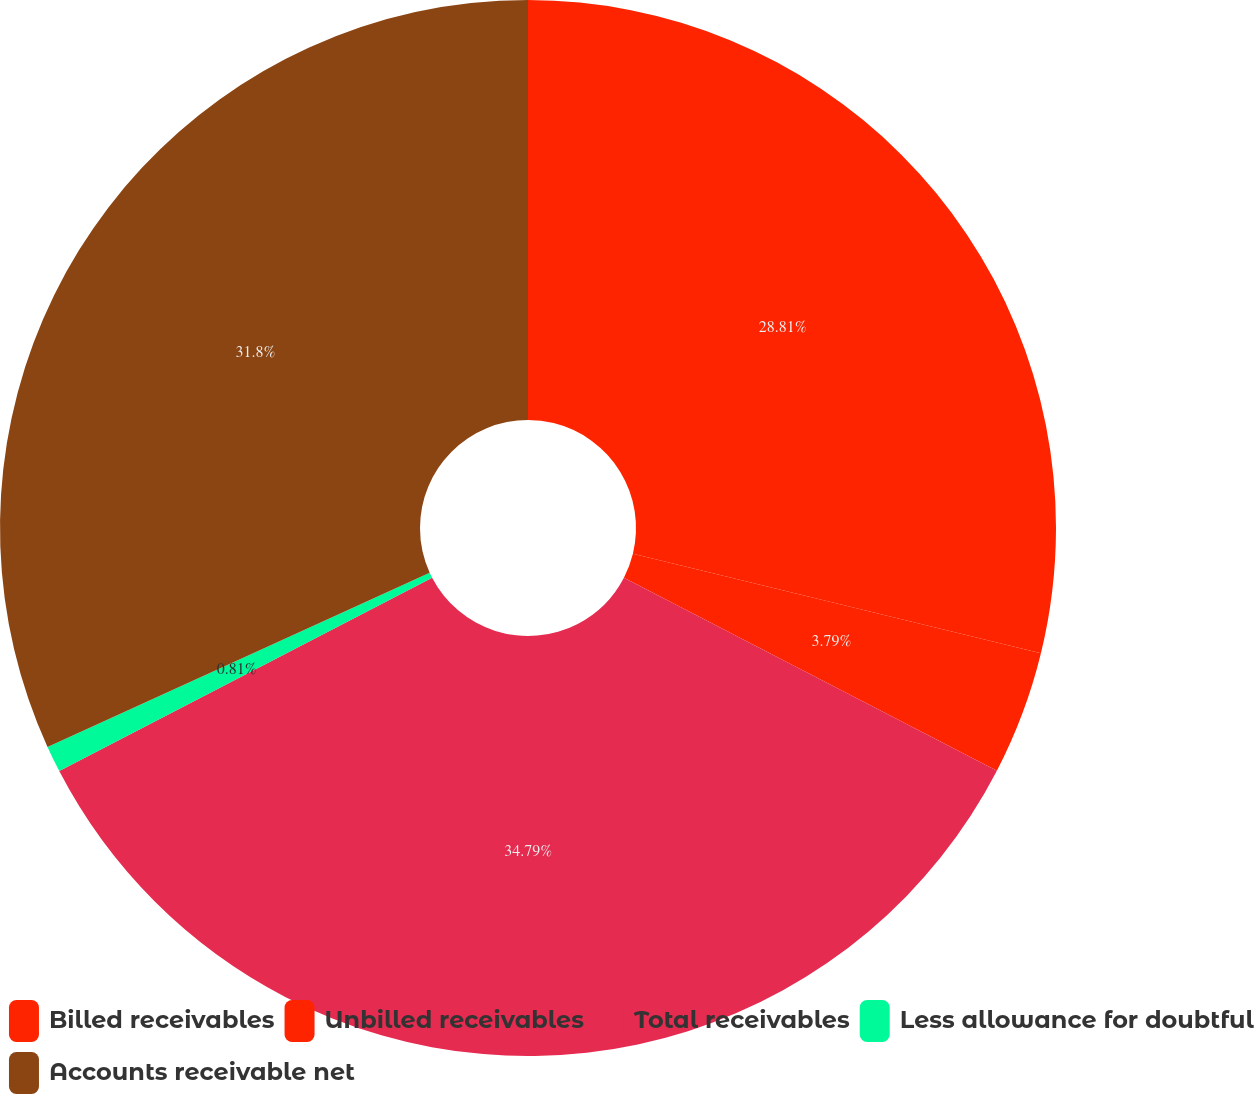Convert chart. <chart><loc_0><loc_0><loc_500><loc_500><pie_chart><fcel>Billed receivables<fcel>Unbilled receivables<fcel>Total receivables<fcel>Less allowance for doubtful<fcel>Accounts receivable net<nl><fcel>28.81%<fcel>3.79%<fcel>34.78%<fcel>0.81%<fcel>31.8%<nl></chart> 